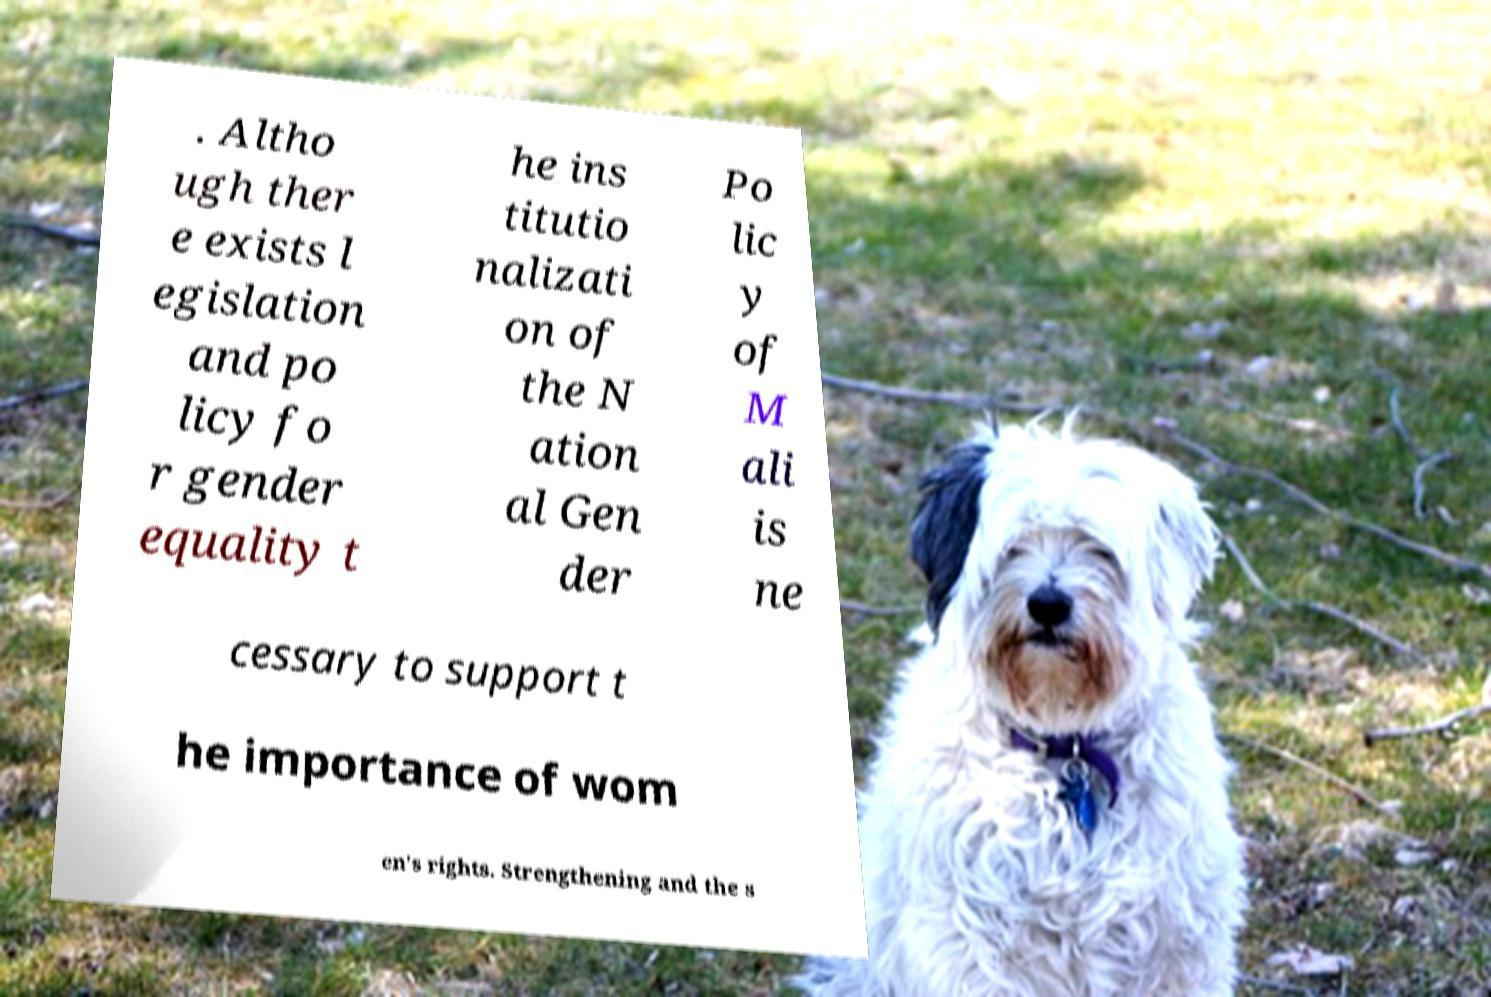Can you accurately transcribe the text from the provided image for me? . Altho ugh ther e exists l egislation and po licy fo r gender equality t he ins titutio nalizati on of the N ation al Gen der Po lic y of M ali is ne cessary to support t he importance of wom en's rights. Strengthening and the s 